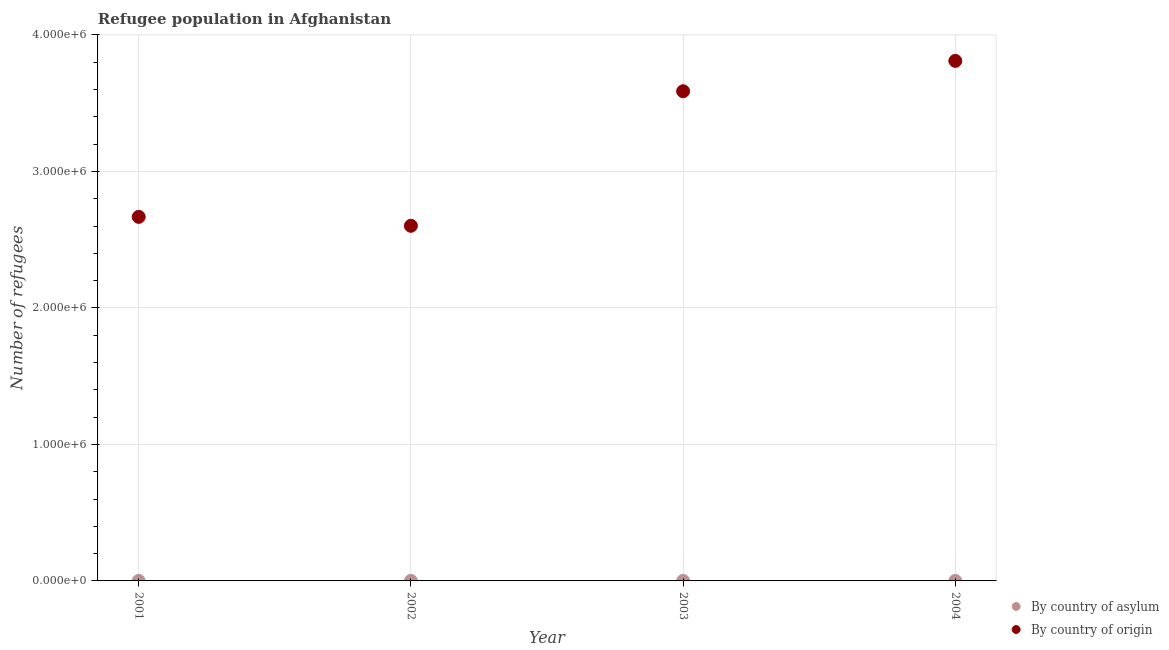What is the number of refugees by country of asylum in 2003?
Provide a short and direct response. 22. Across all years, what is the maximum number of refugees by country of origin?
Your answer should be very brief. 3.81e+06. Across all years, what is the minimum number of refugees by country of origin?
Your answer should be compact. 2.60e+06. In which year was the number of refugees by country of origin maximum?
Make the answer very short. 2004. What is the total number of refugees by country of origin in the graph?
Keep it short and to the point. 1.27e+07. What is the difference between the number of refugees by country of asylum in 2001 and that in 2004?
Offer a very short reply. -24. What is the difference between the number of refugees by country of asylum in 2003 and the number of refugees by country of origin in 2001?
Your answer should be very brief. -2.67e+06. What is the average number of refugees by country of origin per year?
Make the answer very short. 3.17e+06. In the year 2001, what is the difference between the number of refugees by country of origin and number of refugees by country of asylum?
Ensure brevity in your answer.  2.67e+06. In how many years, is the number of refugees by country of origin greater than 2800000?
Give a very brief answer. 2. What is the ratio of the number of refugees by country of asylum in 2002 to that in 2003?
Provide a short and direct response. 0.14. Is the difference between the number of refugees by country of asylum in 2001 and 2002 greater than the difference between the number of refugees by country of origin in 2001 and 2002?
Ensure brevity in your answer.  No. What is the difference between the highest and the second highest number of refugees by country of origin?
Ensure brevity in your answer.  2.22e+05. What is the difference between the highest and the lowest number of refugees by country of origin?
Your response must be concise. 1.21e+06. In how many years, is the number of refugees by country of origin greater than the average number of refugees by country of origin taken over all years?
Give a very brief answer. 2. Does the number of refugees by country of origin monotonically increase over the years?
Offer a terse response. No. How many dotlines are there?
Make the answer very short. 2. How are the legend labels stacked?
Give a very brief answer. Vertical. What is the title of the graph?
Make the answer very short. Refugee population in Afghanistan. Does "Agricultural land" appear as one of the legend labels in the graph?
Offer a very short reply. No. What is the label or title of the X-axis?
Make the answer very short. Year. What is the label or title of the Y-axis?
Ensure brevity in your answer.  Number of refugees. What is the Number of refugees in By country of asylum in 2001?
Your answer should be very brief. 6. What is the Number of refugees of By country of origin in 2001?
Your answer should be very brief. 2.67e+06. What is the Number of refugees in By country of asylum in 2002?
Ensure brevity in your answer.  3. What is the Number of refugees of By country of origin in 2002?
Your answer should be compact. 2.60e+06. What is the Number of refugees in By country of origin in 2003?
Make the answer very short. 3.59e+06. What is the Number of refugees of By country of asylum in 2004?
Offer a very short reply. 30. What is the Number of refugees in By country of origin in 2004?
Your answer should be compact. 3.81e+06. Across all years, what is the maximum Number of refugees of By country of asylum?
Your answer should be very brief. 30. Across all years, what is the maximum Number of refugees of By country of origin?
Your answer should be very brief. 3.81e+06. Across all years, what is the minimum Number of refugees in By country of asylum?
Your answer should be very brief. 3. Across all years, what is the minimum Number of refugees in By country of origin?
Your response must be concise. 2.60e+06. What is the total Number of refugees in By country of origin in the graph?
Offer a terse response. 1.27e+07. What is the difference between the Number of refugees of By country of origin in 2001 and that in 2002?
Your answer should be compact. 6.54e+04. What is the difference between the Number of refugees of By country of asylum in 2001 and that in 2003?
Your answer should be very brief. -16. What is the difference between the Number of refugees in By country of origin in 2001 and that in 2003?
Provide a short and direct response. -9.20e+05. What is the difference between the Number of refugees in By country of origin in 2001 and that in 2004?
Keep it short and to the point. -1.14e+06. What is the difference between the Number of refugees in By country of asylum in 2002 and that in 2003?
Ensure brevity in your answer.  -19. What is the difference between the Number of refugees of By country of origin in 2002 and that in 2003?
Provide a short and direct response. -9.86e+05. What is the difference between the Number of refugees in By country of asylum in 2002 and that in 2004?
Provide a succinct answer. -27. What is the difference between the Number of refugees of By country of origin in 2002 and that in 2004?
Make the answer very short. -1.21e+06. What is the difference between the Number of refugees in By country of asylum in 2003 and that in 2004?
Ensure brevity in your answer.  -8. What is the difference between the Number of refugees in By country of origin in 2003 and that in 2004?
Ensure brevity in your answer.  -2.22e+05. What is the difference between the Number of refugees in By country of asylum in 2001 and the Number of refugees in By country of origin in 2002?
Offer a very short reply. -2.60e+06. What is the difference between the Number of refugees of By country of asylum in 2001 and the Number of refugees of By country of origin in 2003?
Ensure brevity in your answer.  -3.59e+06. What is the difference between the Number of refugees of By country of asylum in 2001 and the Number of refugees of By country of origin in 2004?
Your response must be concise. -3.81e+06. What is the difference between the Number of refugees in By country of asylum in 2002 and the Number of refugees in By country of origin in 2003?
Provide a short and direct response. -3.59e+06. What is the difference between the Number of refugees of By country of asylum in 2002 and the Number of refugees of By country of origin in 2004?
Keep it short and to the point. -3.81e+06. What is the difference between the Number of refugees in By country of asylum in 2003 and the Number of refugees in By country of origin in 2004?
Provide a succinct answer. -3.81e+06. What is the average Number of refugees in By country of asylum per year?
Offer a terse response. 15.25. What is the average Number of refugees in By country of origin per year?
Provide a short and direct response. 3.17e+06. In the year 2001, what is the difference between the Number of refugees in By country of asylum and Number of refugees in By country of origin?
Offer a terse response. -2.67e+06. In the year 2002, what is the difference between the Number of refugees in By country of asylum and Number of refugees in By country of origin?
Keep it short and to the point. -2.60e+06. In the year 2003, what is the difference between the Number of refugees in By country of asylum and Number of refugees in By country of origin?
Keep it short and to the point. -3.59e+06. In the year 2004, what is the difference between the Number of refugees in By country of asylum and Number of refugees in By country of origin?
Your answer should be compact. -3.81e+06. What is the ratio of the Number of refugees in By country of origin in 2001 to that in 2002?
Your answer should be compact. 1.03. What is the ratio of the Number of refugees in By country of asylum in 2001 to that in 2003?
Your response must be concise. 0.27. What is the ratio of the Number of refugees in By country of origin in 2001 to that in 2003?
Your answer should be compact. 0.74. What is the ratio of the Number of refugees of By country of asylum in 2001 to that in 2004?
Provide a short and direct response. 0.2. What is the ratio of the Number of refugees of By country of origin in 2001 to that in 2004?
Ensure brevity in your answer.  0.7. What is the ratio of the Number of refugees in By country of asylum in 2002 to that in 2003?
Your response must be concise. 0.14. What is the ratio of the Number of refugees of By country of origin in 2002 to that in 2003?
Provide a succinct answer. 0.73. What is the ratio of the Number of refugees in By country of asylum in 2002 to that in 2004?
Provide a succinct answer. 0.1. What is the ratio of the Number of refugees of By country of origin in 2002 to that in 2004?
Provide a succinct answer. 0.68. What is the ratio of the Number of refugees of By country of asylum in 2003 to that in 2004?
Your response must be concise. 0.73. What is the ratio of the Number of refugees of By country of origin in 2003 to that in 2004?
Keep it short and to the point. 0.94. What is the difference between the highest and the second highest Number of refugees of By country of origin?
Make the answer very short. 2.22e+05. What is the difference between the highest and the lowest Number of refugees of By country of asylum?
Offer a terse response. 27. What is the difference between the highest and the lowest Number of refugees of By country of origin?
Make the answer very short. 1.21e+06. 